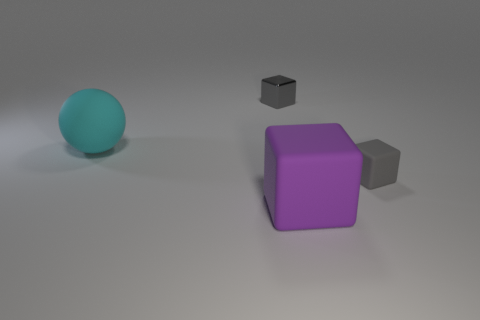Add 3 purple rubber objects. How many objects exist? 7 Subtract all balls. How many objects are left? 3 Add 4 cyan spheres. How many cyan spheres are left? 5 Add 3 cyan spheres. How many cyan spheres exist? 4 Subtract 1 purple cubes. How many objects are left? 3 Subtract all big cyan objects. Subtract all small gray blocks. How many objects are left? 1 